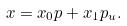Convert formula to latex. <formula><loc_0><loc_0><loc_500><loc_500>x = x _ { 0 } p + x _ { 1 } p _ { u } .</formula> 